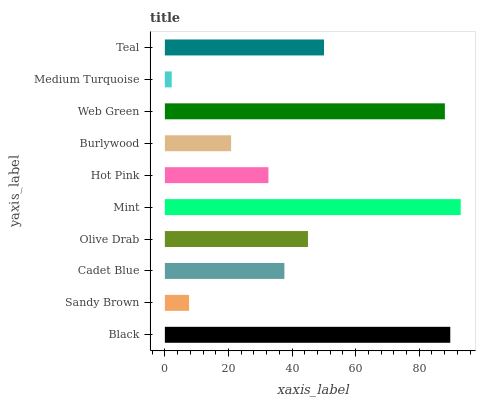Is Medium Turquoise the minimum?
Answer yes or no. Yes. Is Mint the maximum?
Answer yes or no. Yes. Is Sandy Brown the minimum?
Answer yes or no. No. Is Sandy Brown the maximum?
Answer yes or no. No. Is Black greater than Sandy Brown?
Answer yes or no. Yes. Is Sandy Brown less than Black?
Answer yes or no. Yes. Is Sandy Brown greater than Black?
Answer yes or no. No. Is Black less than Sandy Brown?
Answer yes or no. No. Is Olive Drab the high median?
Answer yes or no. Yes. Is Cadet Blue the low median?
Answer yes or no. Yes. Is Medium Turquoise the high median?
Answer yes or no. No. Is Burlywood the low median?
Answer yes or no. No. 